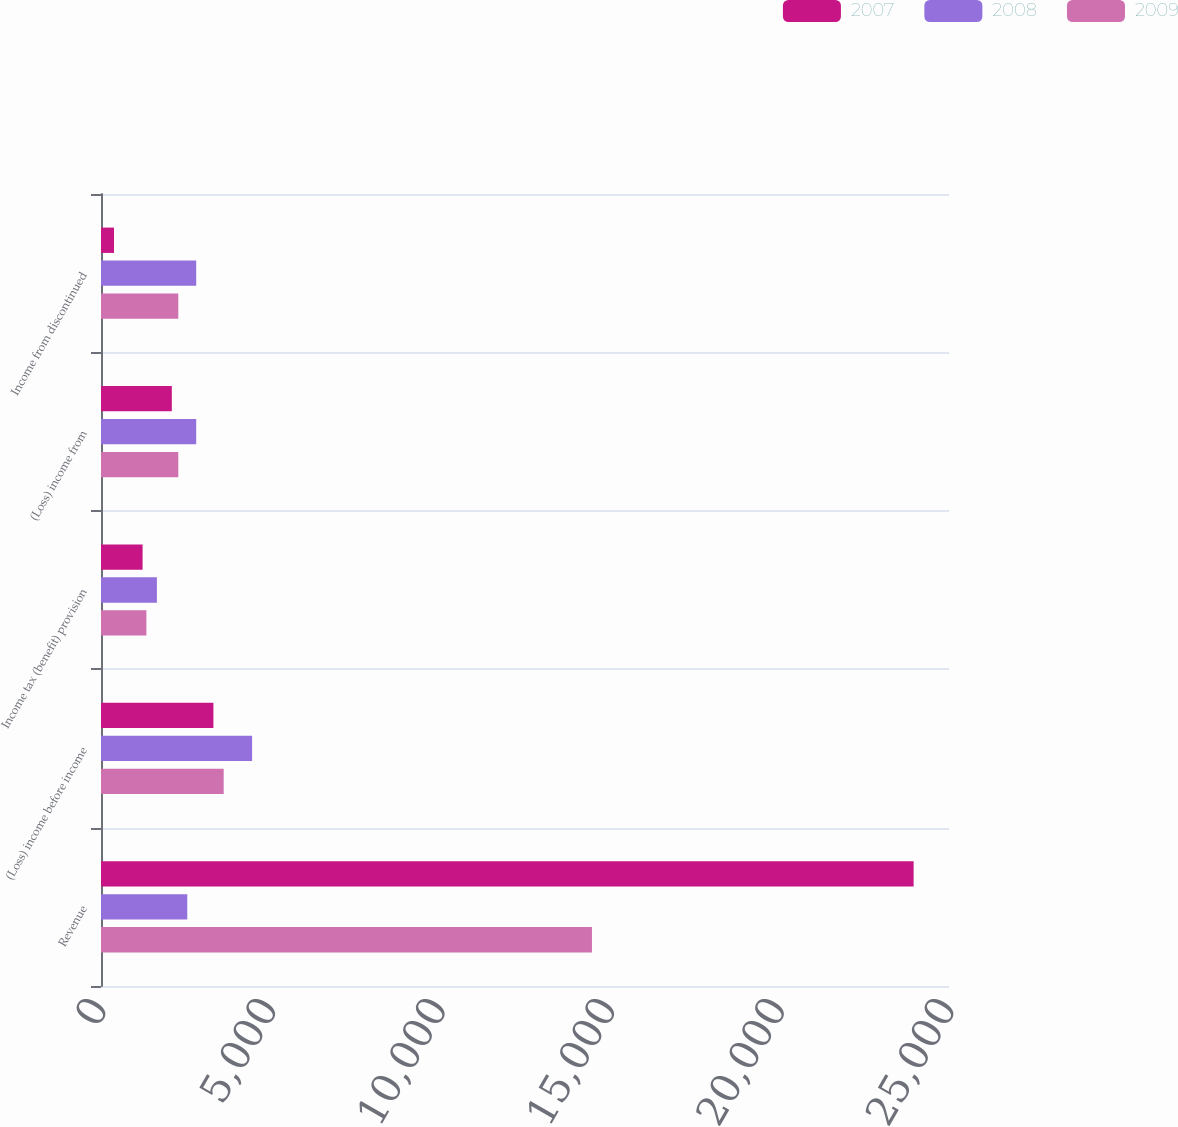Convert chart. <chart><loc_0><loc_0><loc_500><loc_500><stacked_bar_chart><ecel><fcel>Revenue<fcel>(Loss) income before income<fcel>Income tax (benefit) provision<fcel>(Loss) income from<fcel>Income from discontinued<nl><fcel>2007<fcel>23957<fcel>3314<fcel>1226<fcel>2088<fcel>384<nl><fcel>2008<fcel>2543<fcel>4455<fcel>1648<fcel>2807<fcel>2807<nl><fcel>2009<fcel>14474<fcel>3617<fcel>1338<fcel>2279<fcel>2279<nl></chart> 